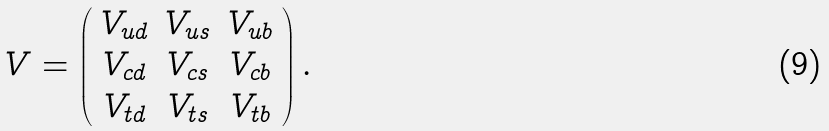<formula> <loc_0><loc_0><loc_500><loc_500>V = \left ( \begin{array} { c c c } V _ { u d } & V _ { u s } & V _ { u b } \\ V _ { c d } & V _ { c s } & V _ { c b } \\ V _ { t d } & V _ { t s } & V _ { t b } \end{array} \right ) .</formula> 